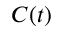<formula> <loc_0><loc_0><loc_500><loc_500>C ( t )</formula> 